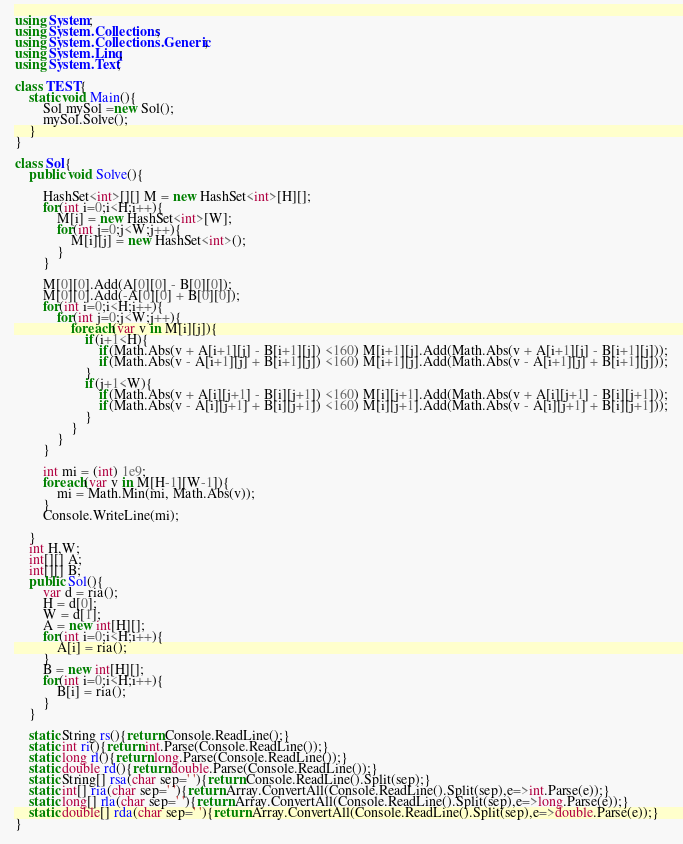<code> <loc_0><loc_0><loc_500><loc_500><_C#_>using System;
using System.Collections;
using System.Collections.Generic;
using System.Linq;
using System.Text;

class TEST{
	static void Main(){
		Sol mySol =new Sol();
		mySol.Solve();
	}
}

class Sol{
	public void Solve(){
		
		HashSet<int>[][] M = new HashSet<int>[H][];
		for(int i=0;i<H;i++){
			M[i] = new HashSet<int>[W];
			for(int j=0;j<W;j++){
				M[i][j] = new HashSet<int>();
			}
		}
		
		M[0][0].Add(A[0][0] - B[0][0]);
		M[0][0].Add(-A[0][0] + B[0][0]);
		for(int i=0;i<H;i++){
			for(int j=0;j<W;j++){
				foreach(var v in M[i][j]){
					if(i+1<H){
						if(Math.Abs(v + A[i+1][j] - B[i+1][j]) <160) M[i+1][j].Add(Math.Abs(v + A[i+1][j] - B[i+1][j]));
						if(Math.Abs(v - A[i+1][j] + B[i+1][j]) <160) M[i+1][j].Add(Math.Abs(v - A[i+1][j] + B[i+1][j]));
					}
					if(j+1<W){
						if(Math.Abs(v + A[i][j+1] - B[i][j+1]) <160) M[i][j+1].Add(Math.Abs(v + A[i][j+1] - B[i][j+1]));
						if(Math.Abs(v - A[i][j+1] + B[i][j+1]) <160) M[i][j+1].Add(Math.Abs(v - A[i][j+1] + B[i][j+1]));
					}
				}
			}
		}
		
		int mi = (int) 1e9;
		foreach(var v in M[H-1][W-1]){
			mi = Math.Min(mi, Math.Abs(v));
		}
		Console.WriteLine(mi);
		
	}
	int H,W;
	int[][] A;
	int[][] B;
	public Sol(){
		var d = ria();
		H = d[0];
		W = d[1];
		A = new int[H][];
		for(int i=0;i<H;i++){
			A[i] = ria();
		}
		B = new int[H][];
		for(int i=0;i<H;i++){
			B[i] = ria();
		}
	}

	static String rs(){return Console.ReadLine();}
	static int ri(){return int.Parse(Console.ReadLine());}
	static long rl(){return long.Parse(Console.ReadLine());}
	static double rd(){return double.Parse(Console.ReadLine());}
	static String[] rsa(char sep=' '){return Console.ReadLine().Split(sep);}
	static int[] ria(char sep=' '){return Array.ConvertAll(Console.ReadLine().Split(sep),e=>int.Parse(e));}
	static long[] rla(char sep=' '){return Array.ConvertAll(Console.ReadLine().Split(sep),e=>long.Parse(e));}
	static double[] rda(char sep=' '){return Array.ConvertAll(Console.ReadLine().Split(sep),e=>double.Parse(e));}
}
</code> 